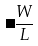<formula> <loc_0><loc_0><loc_500><loc_500>\Delta \frac { W } { L }</formula> 